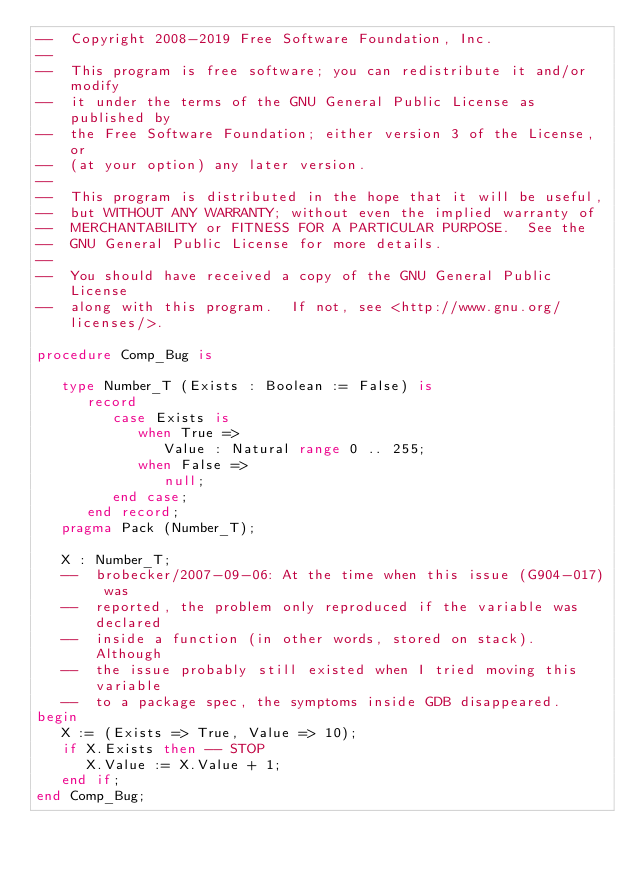Convert code to text. <code><loc_0><loc_0><loc_500><loc_500><_Ada_>--  Copyright 2008-2019 Free Software Foundation, Inc.
--
--  This program is free software; you can redistribute it and/or modify
--  it under the terms of the GNU General Public License as published by
--  the Free Software Foundation; either version 3 of the License, or
--  (at your option) any later version.
--
--  This program is distributed in the hope that it will be useful,
--  but WITHOUT ANY WARRANTY; without even the implied warranty of
--  MERCHANTABILITY or FITNESS FOR A PARTICULAR PURPOSE.  See the
--  GNU General Public License for more details.
--
--  You should have received a copy of the GNU General Public License
--  along with this program.  If not, see <http://www.gnu.org/licenses/>.

procedure Comp_Bug is

   type Number_T (Exists : Boolean := False) is
      record
         case Exists is
            when True =>
               Value : Natural range 0 .. 255;
            when False =>
               null;
         end case;
      end record;
   pragma Pack (Number_T);

   X : Number_T;
   --  brobecker/2007-09-06: At the time when this issue (G904-017) was
   --  reported, the problem only reproduced if the variable was declared
   --  inside a function (in other words, stored on stack).  Although
   --  the issue probably still existed when I tried moving this variable
   --  to a package spec, the symptoms inside GDB disappeared.
begin
   X := (Exists => True, Value => 10);
   if X.Exists then -- STOP
      X.Value := X.Value + 1;
   end if;
end Comp_Bug;
</code> 